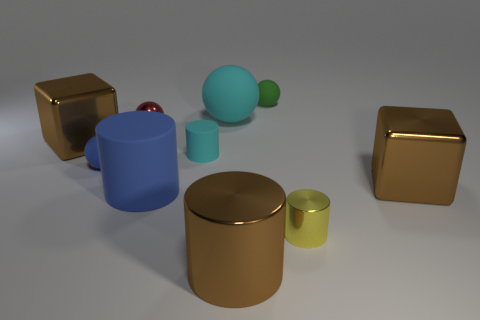Can you describe the lighting direction in the image? The lighting in the image appears to be coming from the upper right corner, as indicated by the shadows being cast to the lower left of the objects. This lighting creates a soft appearance on the surfaces and helps highlight the textures of the various materials.  How does the lighting affect the perceived colors of the objects? The lighting brings out the vibrancy and depth of the objects' colors. It enhances the golden hue of the metallic objects, gives the red sphere a rich glossiness, and provides a contrast that makes the green objects stand out despite their matte finish. 